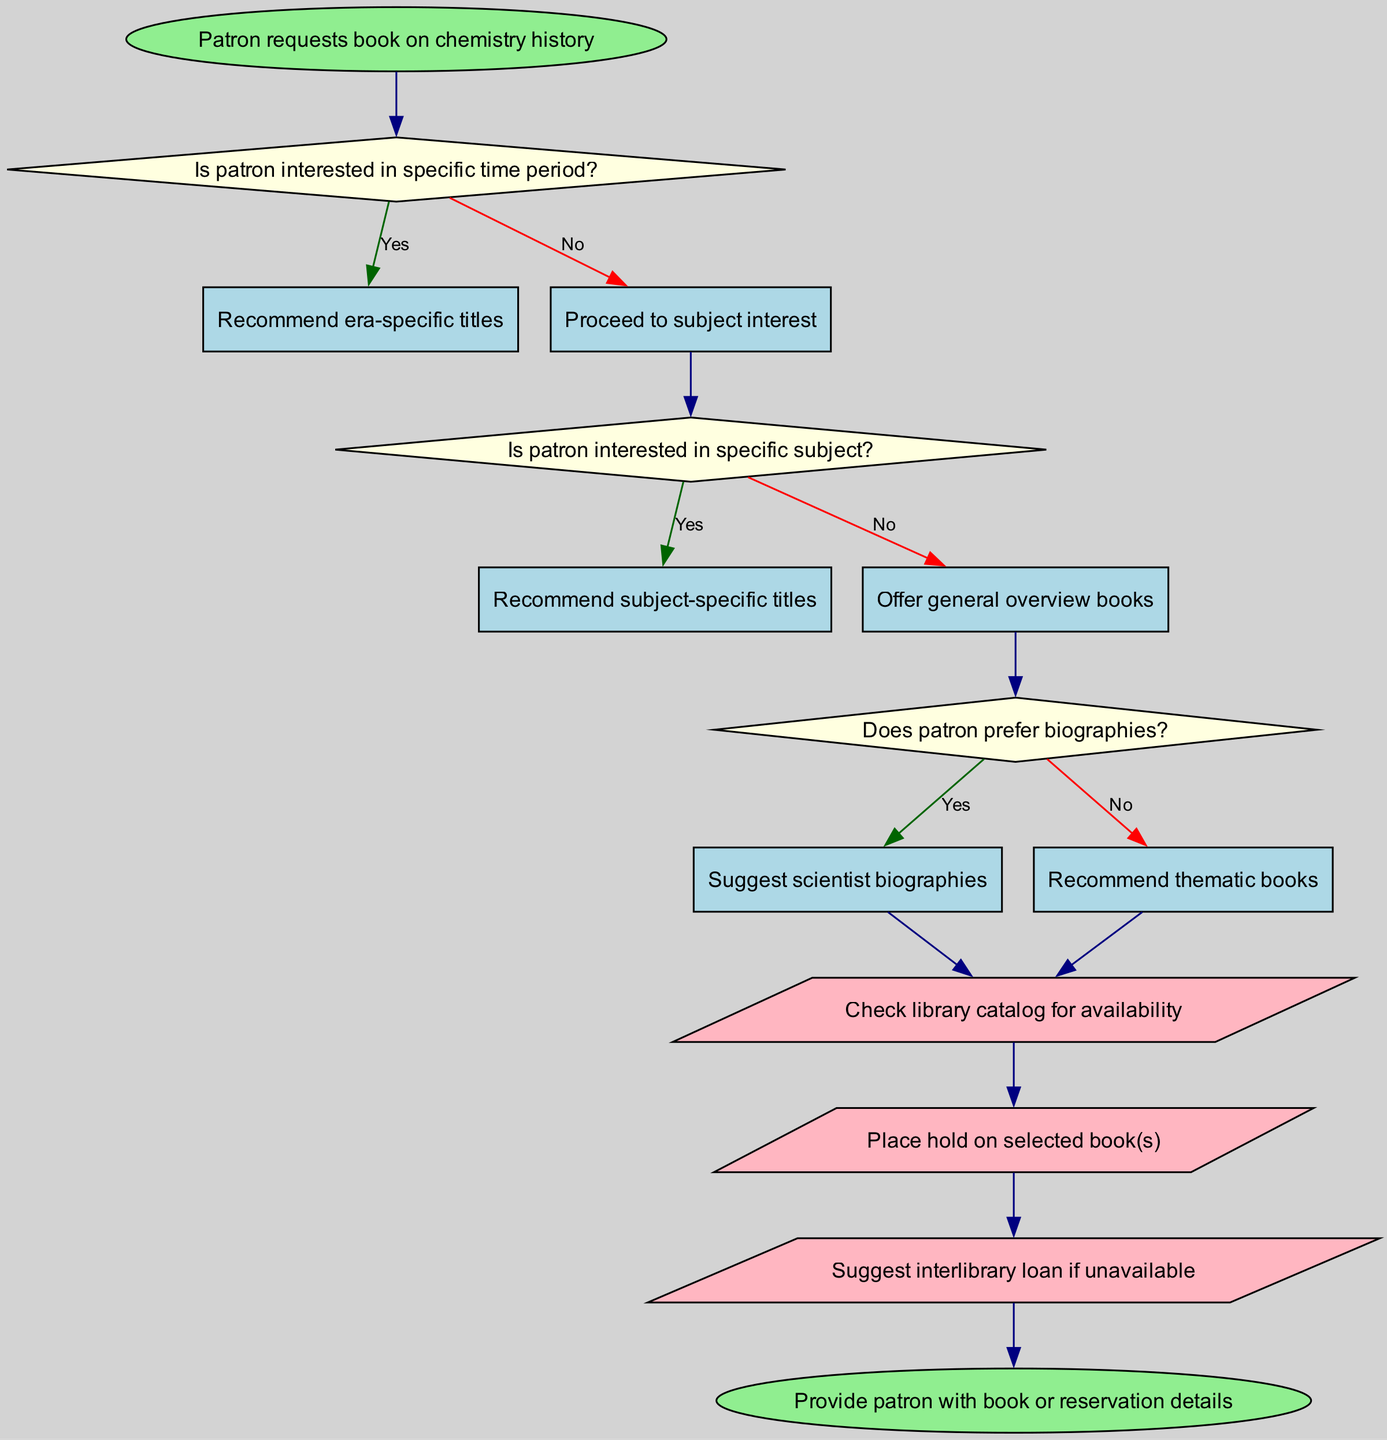What is the starting point of the diagram? The diagram begins with the node labeled "Patron requests book on chemistry history," which signifies the initiation of the book recommendation process.
Answer: Patron requests book on chemistry history How many decision nodes are present in the diagram? Counting the distinct nodes where decisions are made, there are three decision nodes that lead to different pathways based on the patron's interests.
Answer: 3 What happens if the patron is interested in a specific time period? If the patron indicates an interest in a specific time period, the flow proceeds to the recommendation of era-specific titles, demonstrating a focused response to their request.
Answer: Recommend era-specific titles What is the next step if the patron does not have a specific subject interest? If the patron is not interested in a specific subject, the flow moves to offer general overview books, which aims to give a broader context about chemistry history.
Answer: Offer general overview books What actions are taken after recommending books? After recommending the books, actions include checking library catalog for availability, placing a hold on selected book(s), and suggesting an interlibrary loan if the requested titles are not available.
Answer: Check library catalog for availability, Place hold on selected book(s), Suggest interlibrary loan if unavailable What does the diagram lead to if the patron prefers biographies? If the patron prefers biographies, the flow corresponds to the recommendation of scientist biographies, indicating a specific interest in personal stories within the realm of chemistry.
Answer: Suggest scientist biographies What is the final output of the recommendation process? The process culminates in providing the patron with book or reservation details, ensuring that they receive the necessary information to acquire the titles suggested during the recommendation flow.
Answer: Provide patron with book or reservation details What color represents the decision nodes in the diagram? The decision nodes in the diagram are colored light yellow, distinguishing them from other types of nodes such as actions or starting/ending points.
Answer: Light yellow What does the flow chart suggest if the patron answers 'no' to having a specific subject? If the patron answers 'no' to having a specific subject interest, the flow directs to offer general overview books, indicating a generalized selection approach.
Answer: Offer general overview books 